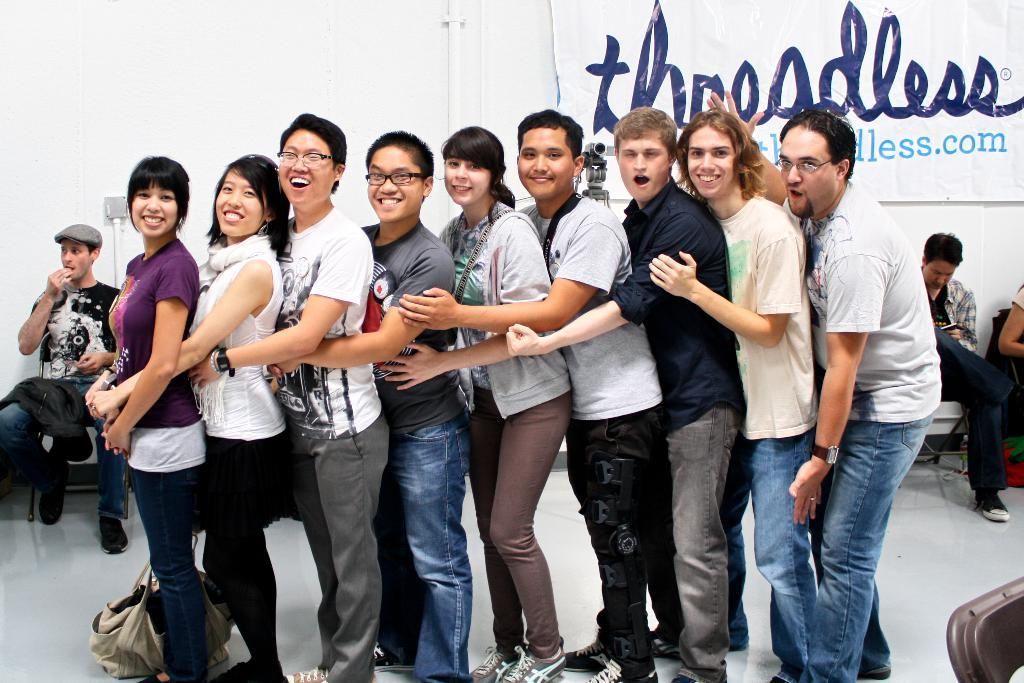What are the people in the image doing? There are people standing and holding each other, as well as people sitting on chairs in the image. What can be seen on the wall in the image? There is a banner on the wall in the image. What type of beetle can be seen crawling on the banner in the image? There is no beetle present in the image; the banner is the only item mentioned on the wall. 